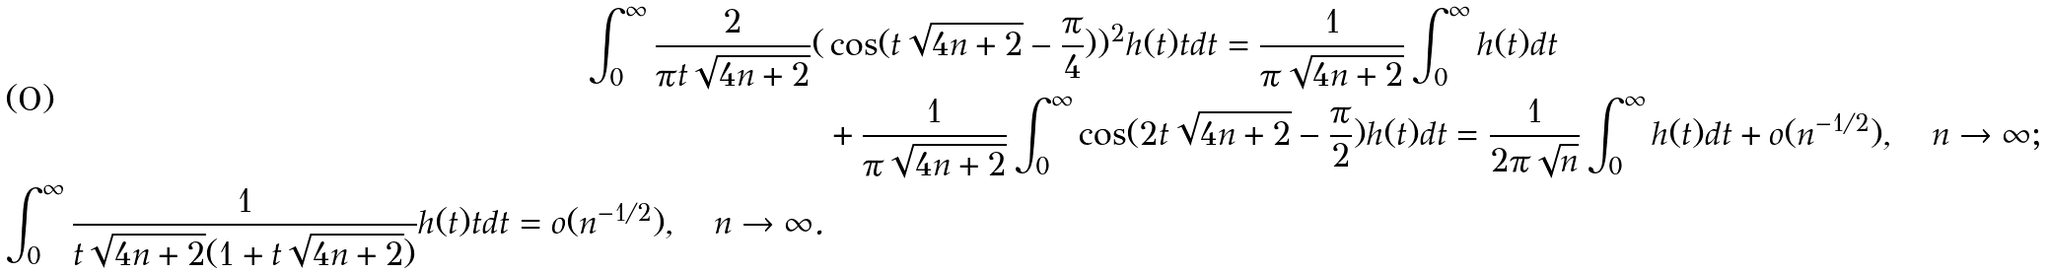Convert formula to latex. <formula><loc_0><loc_0><loc_500><loc_500>\int _ { 0 } ^ { \infty } \frac { 2 } { \pi t \sqrt { 4 n + 2 } } ( & \cos ( t \sqrt { 4 n + 2 } - \frac { \pi } { 4 } ) ) ^ { 2 } h ( t ) t d t = \frac { 1 } { \pi \sqrt { 4 n + 2 } } \int _ { 0 } ^ { \infty } h ( t ) d t \\ & + \frac { 1 } { \pi \sqrt { 4 n + 2 } } \int _ { 0 } ^ { \infty } \cos ( 2 t \sqrt { 4 n + 2 } - \frac { \pi } { 2 } ) h ( t ) d t = \frac { 1 } { 2 \pi \sqrt { n } } \int _ { 0 } ^ { \infty } h ( t ) d t + o ( n ^ { - 1 / 2 } ) , \quad n \to \infty ; \\ \int _ { 0 } ^ { \infty } \frac { 1 } { t \sqrt { 4 n + 2 } ( 1 + t \sqrt { 4 n + 2 } ) } h ( t ) t d t = o ( n ^ { - 1 / 2 } ) , \quad n \to \infty .</formula> 